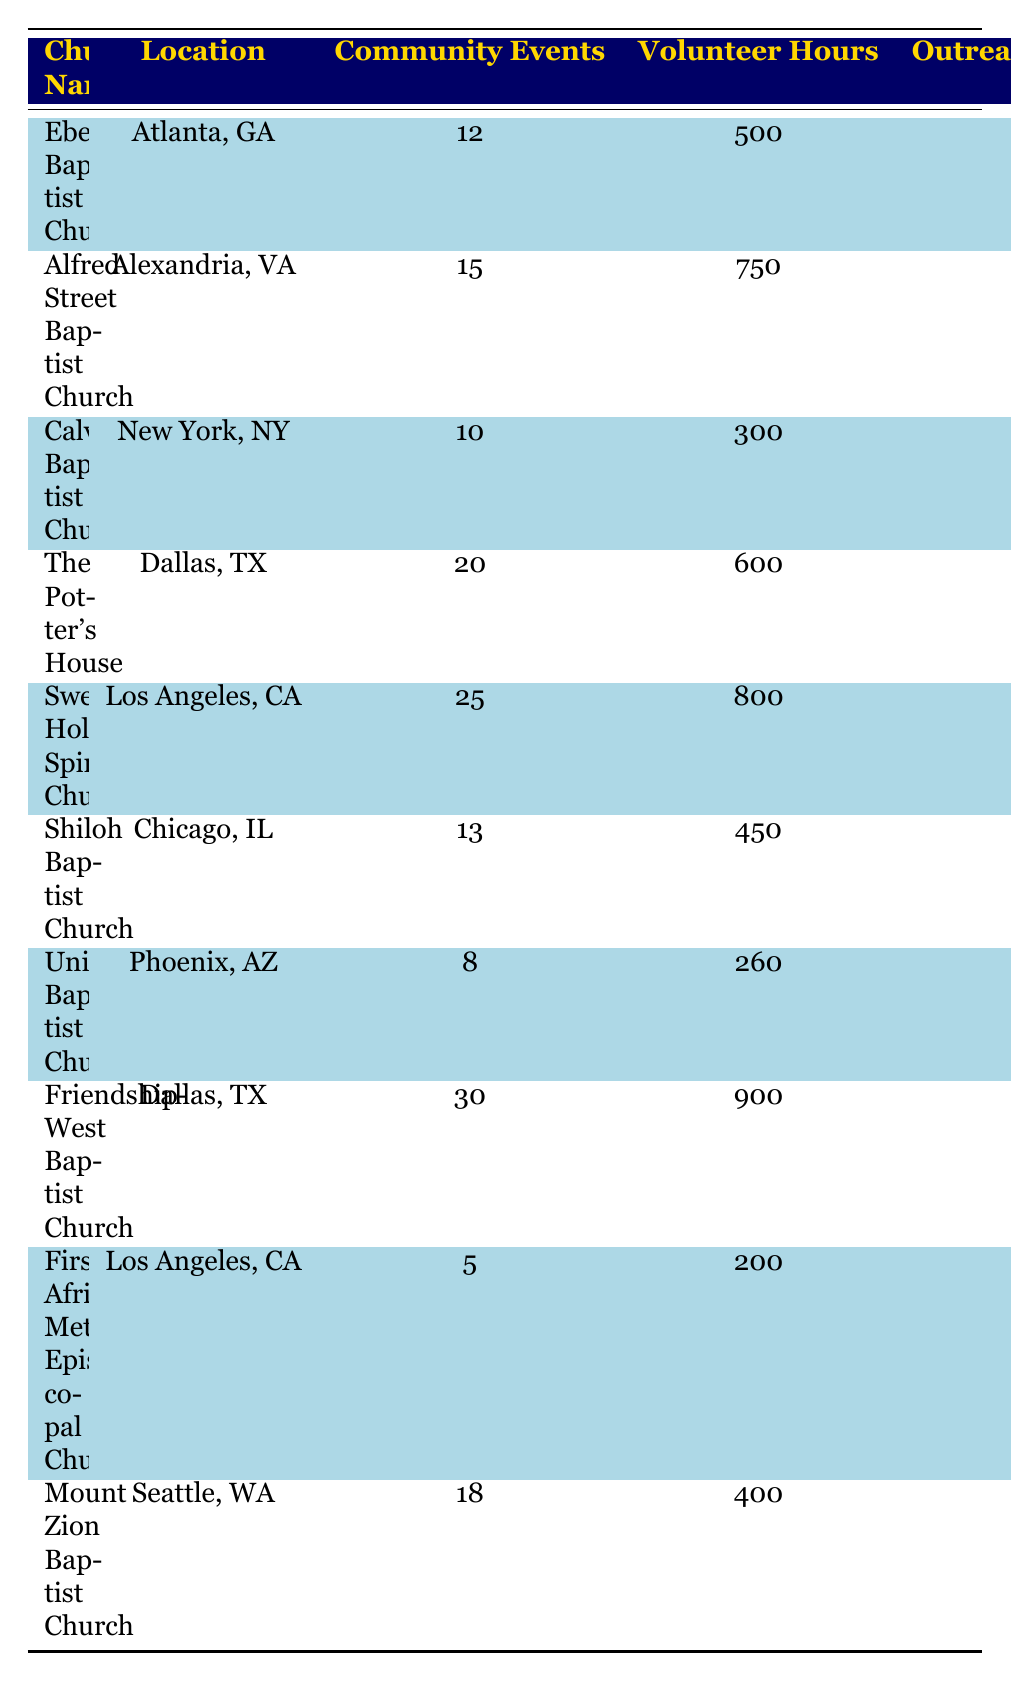What is the location of Friendship-West Baptist Church? The table directly lists the location for each church. For Friendship-West Baptist Church, it shows "Dallas, TX".
Answer: Dallas, TX How many community events did Sweet Holy Spirit Church organize in 2022? The table lists the number of community events for each church. For Sweet Holy Spirit Church, it indicates 25 community events.
Answer: 25 Which church had the highest member participation in 2022? To find the church with the highest member participation, I compare the Member Participation numbers across all churches. Friendship-West Baptist Church has 240 members, which is the highest.
Answer: Friendship-West Baptist Church What is the total number of volunteer hours recorded for all churches combined? To find the total volunteer hours, I sum the Volunteer Hours for all churches: 500 + 750 + 300 + 600 + 800 + 450 + 260 + 900 + 200 + 400 = 5120 hours.
Answer: 5120 Which church had the least youth engagement among the listed churches? By comparing the Youth Engagement figures in the table, First African Methodist Episcopal Church has the lowest number at 15.
Answer: First African Methodist Episcopal Church What is the average number of community events per church? First, I count the number of churches, which is 10. Then, I sum the Community Events: 12 + 15 + 10 + 20 + 25 + 13 + 8 + 30 + 5 + 18 =  156. Finally, I divide by 10 for the average: 156 / 10 = 15.6.
Answer: 15.6 Is it true that at least one church had more than 700 volunteer hours? I check the Volunteer Hours for each church. Alfred Street Baptist Church (750), Sweet Holy Spirit Church (800), and Friendship-West Baptist Church (900) all have over 700 hours, confirming the statement is true.
Answer: Yes Which church organized more community events: The Potter's House or Mount Zion Baptist Church? I compare community events for both churches. The Potter's House organized 20 events, while Mount Zion Baptist Church organized 18. Therefore, The Potter's House had more.
Answer: The Potter's House What is the difference in outreach programs between Ebenezer Baptist Church and Sweet Holy Spirit Church? Ebenezer Baptist Church has 3 outreach programs, while Sweet Holy Spirit Church has 7. The difference is calculated as 7 - 3 = 4.
Answer: 4 Which church had the highest youth engagement and how many youth were engaged? Checking the Youth Engagement numbers, Friendship-West Baptist Church has the highest engagement with 90 youth participating.
Answer: Friendship-West Baptist Church, 90 youth If you combine the volunteer hours of Union Baptist Church and First African Methodist Episcopal Church, what total do you get? Union Baptist Church has 260 volunteer hours and First African Methodist Episcopal Church has 200. The total is calculated as 260 + 200 = 460.
Answer: 460 